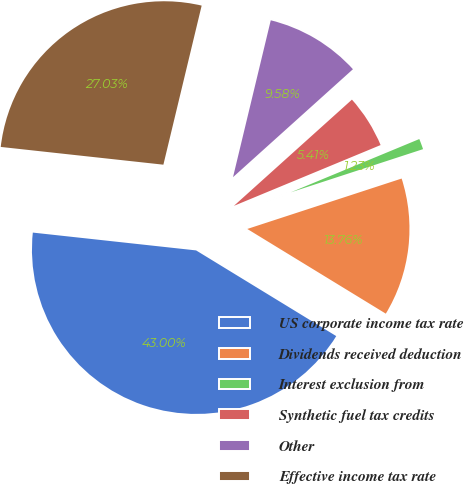<chart> <loc_0><loc_0><loc_500><loc_500><pie_chart><fcel>US corporate income tax rate<fcel>Dividends received deduction<fcel>Interest exclusion from<fcel>Synthetic fuel tax credits<fcel>Other<fcel>Effective income tax rate<nl><fcel>43.0%<fcel>13.76%<fcel>1.23%<fcel>5.41%<fcel>9.58%<fcel>27.03%<nl></chart> 